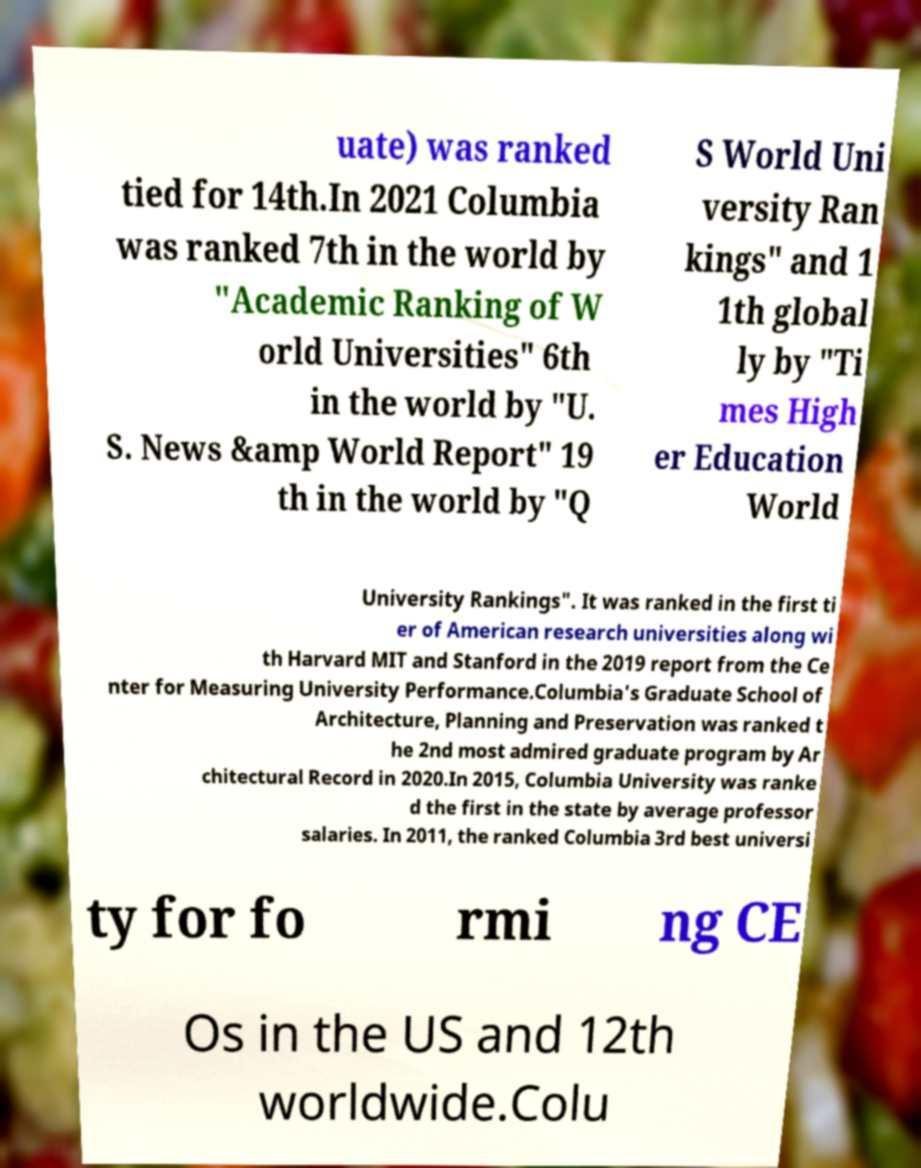Can you read and provide the text displayed in the image?This photo seems to have some interesting text. Can you extract and type it out for me? uate) was ranked tied for 14th.In 2021 Columbia was ranked 7th in the world by "Academic Ranking of W orld Universities" 6th in the world by "U. S. News &amp World Report" 19 th in the world by "Q S World Uni versity Ran kings" and 1 1th global ly by "Ti mes High er Education World University Rankings". It was ranked in the first ti er of American research universities along wi th Harvard MIT and Stanford in the 2019 report from the Ce nter for Measuring University Performance.Columbia's Graduate School of Architecture, Planning and Preservation was ranked t he 2nd most admired graduate program by Ar chitectural Record in 2020.In 2015, Columbia University was ranke d the first in the state by average professor salaries. In 2011, the ranked Columbia 3rd best universi ty for fo rmi ng CE Os in the US and 12th worldwide.Colu 